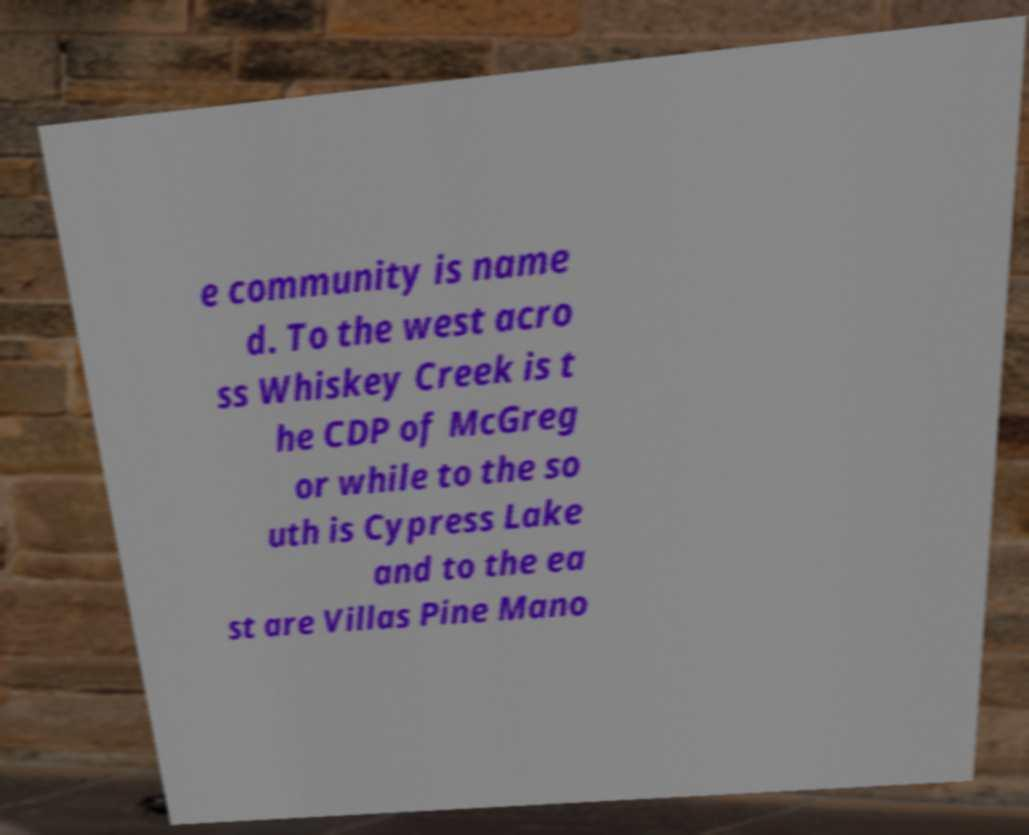Could you assist in decoding the text presented in this image and type it out clearly? e community is name d. To the west acro ss Whiskey Creek is t he CDP of McGreg or while to the so uth is Cypress Lake and to the ea st are Villas Pine Mano 